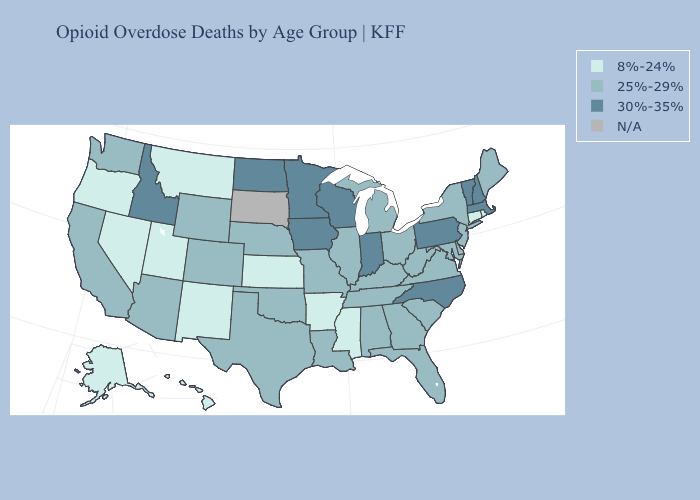What is the highest value in the West ?
Give a very brief answer. 30%-35%. What is the lowest value in the USA?
Concise answer only. 8%-24%. What is the lowest value in states that border Tennessee?
Concise answer only. 8%-24%. What is the value of Alabama?
Short answer required. 25%-29%. Does the map have missing data?
Keep it brief. Yes. What is the highest value in the USA?
Be succinct. 30%-35%. Name the states that have a value in the range 25%-29%?
Answer briefly. Alabama, Arizona, California, Colorado, Delaware, Florida, Georgia, Illinois, Kentucky, Louisiana, Maine, Maryland, Michigan, Missouri, Nebraska, New Jersey, New York, Ohio, Oklahoma, South Carolina, Tennessee, Texas, Virginia, Washington, West Virginia, Wyoming. Among the states that border Idaho , does Wyoming have the highest value?
Give a very brief answer. Yes. What is the highest value in the South ?
Short answer required. 30%-35%. Does the first symbol in the legend represent the smallest category?
Give a very brief answer. Yes. What is the value of Vermont?
Keep it brief. 30%-35%. Name the states that have a value in the range 30%-35%?
Keep it brief. Idaho, Indiana, Iowa, Massachusetts, Minnesota, New Hampshire, North Carolina, North Dakota, Pennsylvania, Vermont, Wisconsin. Name the states that have a value in the range 8%-24%?
Answer briefly. Alaska, Arkansas, Connecticut, Hawaii, Kansas, Mississippi, Montana, Nevada, New Mexico, Oregon, Rhode Island, Utah. Name the states that have a value in the range N/A?
Give a very brief answer. South Dakota. Name the states that have a value in the range 25%-29%?
Quick response, please. Alabama, Arizona, California, Colorado, Delaware, Florida, Georgia, Illinois, Kentucky, Louisiana, Maine, Maryland, Michigan, Missouri, Nebraska, New Jersey, New York, Ohio, Oklahoma, South Carolina, Tennessee, Texas, Virginia, Washington, West Virginia, Wyoming. 